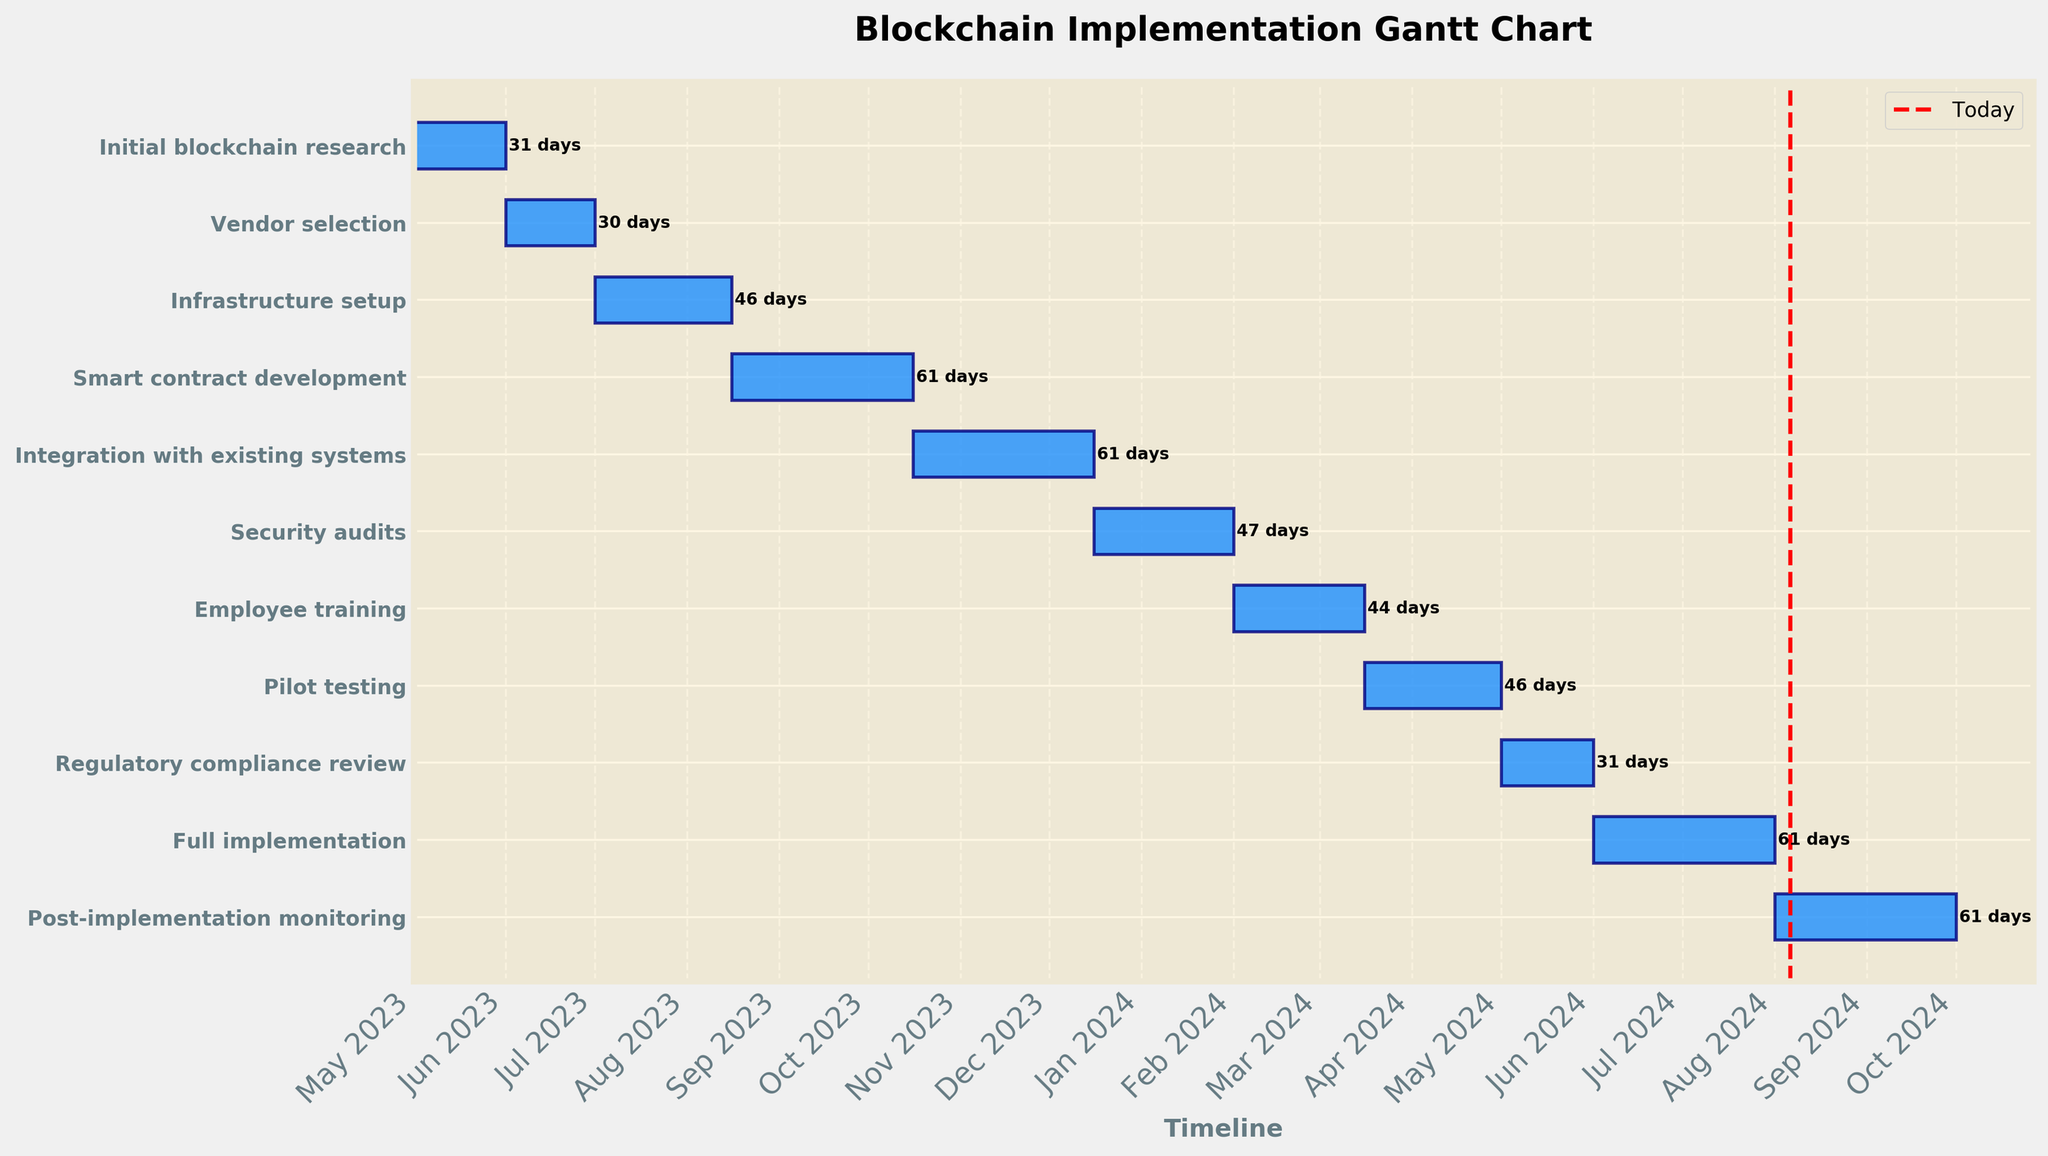What is the title of the Gantt chart? The title is usually placed at the top of the chart and indicates the main subject or focus. In this case, it is mentioned in the figure description.
Answer: Blockchain Implementation Gantt Chart What is the total duration of the "Employee training" task? You can find this information by locating the "Employee training" task on the y-axis and looking at the duration label at the end of the bar.
Answer: 44 days Which task starts immediately after "Vendor selection"? To find this, identify the end date of "Vendor selection" and look for the task that starts on the next day. "Vendor selection" ends on 2023-06-30.
Answer: Infrastructure setup How many tasks have a duration of more than 60 days? To answer this, go through the duration labels of each task and count the number of tasks where the duration exceeds 60 days.
Answer: 4 Which task involves the longest period, and what is its duration? Locate the task with the longest horizontal bar and check its duration. The longest bar corresponds to "Integration with existing systems" and "Full implementation".
Answer: 61 days What is the difference in duration between "Pilot testing" and "Security audits"? "Pilot testing" has a duration of 46 days and "Security audits" has a duration of 47 days. The difference is the absolute value of the subtraction 47 - 46.
Answer: 1 day Which task is scheduled to end closest to the current date? Identify the red "Today" line and look for the task ending date that is nearest to this line. Since the current date is not provided precisely, assume it's before Aug 2023 based on end date courses.
Answer: Initial blockchain research What are the start and end dates of the "Smart contract development" task? Look for the "Smart contract development" task on the y-axis and find the start and end dates attached to it.
Answer: 2023-08-16 to 2023-10-15 How many tasks overlap with the "Integration with existing systems" task? "Integration with existing systems" runs from 2023-10-16 to 2023-12-15. Analyze the other task periods to count overlaps within this range (ends of "Smart contract development", "Security audits", and starts "Employee training").
Answer: 3 Which task directly precedes "Post-implementation monitoring"? Identify the task scheduled immediately before "Post-implementation monitoring" on the y-axis. "Post-implementation monitoring" starts on 2024-08-01.
Answer: Full implementation 